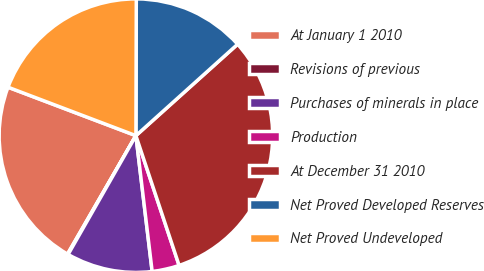Convert chart to OTSL. <chart><loc_0><loc_0><loc_500><loc_500><pie_chart><fcel>At January 1 2010<fcel>Revisions of previous<fcel>Purchases of minerals in place<fcel>Production<fcel>At December 31 2010<fcel>Net Proved Developed Reserves<fcel>Net Proved Undeveloped<nl><fcel>22.43%<fcel>0.08%<fcel>10.15%<fcel>3.22%<fcel>31.54%<fcel>13.3%<fcel>19.28%<nl></chart> 